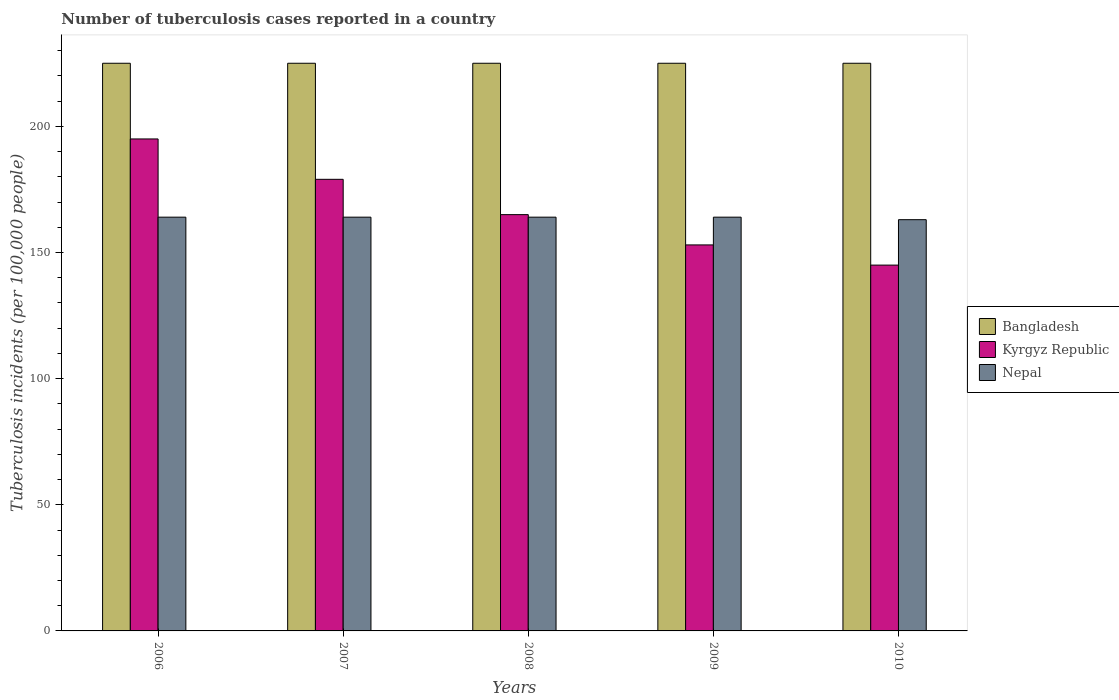How many groups of bars are there?
Provide a succinct answer. 5. What is the label of the 4th group of bars from the left?
Provide a succinct answer. 2009. What is the number of tuberculosis cases reported in in Kyrgyz Republic in 2010?
Provide a succinct answer. 145. Across all years, what is the maximum number of tuberculosis cases reported in in Bangladesh?
Provide a short and direct response. 225. Across all years, what is the minimum number of tuberculosis cases reported in in Bangladesh?
Keep it short and to the point. 225. In which year was the number of tuberculosis cases reported in in Kyrgyz Republic minimum?
Ensure brevity in your answer.  2010. What is the total number of tuberculosis cases reported in in Bangladesh in the graph?
Make the answer very short. 1125. What is the difference between the number of tuberculosis cases reported in in Nepal in 2007 and that in 2010?
Your answer should be very brief. 1. What is the difference between the number of tuberculosis cases reported in in Nepal in 2007 and the number of tuberculosis cases reported in in Bangladesh in 2009?
Your answer should be compact. -61. What is the average number of tuberculosis cases reported in in Nepal per year?
Your answer should be compact. 163.8. In the year 2007, what is the difference between the number of tuberculosis cases reported in in Kyrgyz Republic and number of tuberculosis cases reported in in Nepal?
Keep it short and to the point. 15. In how many years, is the number of tuberculosis cases reported in in Nepal greater than 90?
Your answer should be compact. 5. What is the ratio of the number of tuberculosis cases reported in in Kyrgyz Republic in 2009 to that in 2010?
Offer a terse response. 1.06. What is the difference between the highest and the lowest number of tuberculosis cases reported in in Bangladesh?
Make the answer very short. 0. Is the sum of the number of tuberculosis cases reported in in Nepal in 2007 and 2008 greater than the maximum number of tuberculosis cases reported in in Bangladesh across all years?
Your answer should be compact. Yes. What does the 3rd bar from the left in 2009 represents?
Offer a terse response. Nepal. Is it the case that in every year, the sum of the number of tuberculosis cases reported in in Nepal and number of tuberculosis cases reported in in Bangladesh is greater than the number of tuberculosis cases reported in in Kyrgyz Republic?
Your answer should be compact. Yes. Are all the bars in the graph horizontal?
Your answer should be very brief. No. How many years are there in the graph?
Make the answer very short. 5. Does the graph contain any zero values?
Your answer should be compact. No. Does the graph contain grids?
Offer a terse response. No. How many legend labels are there?
Provide a short and direct response. 3. What is the title of the graph?
Your response must be concise. Number of tuberculosis cases reported in a country. Does "Liberia" appear as one of the legend labels in the graph?
Make the answer very short. No. What is the label or title of the Y-axis?
Offer a terse response. Tuberculosis incidents (per 100,0 people). What is the Tuberculosis incidents (per 100,000 people) of Bangladesh in 2006?
Ensure brevity in your answer.  225. What is the Tuberculosis incidents (per 100,000 people) of Kyrgyz Republic in 2006?
Ensure brevity in your answer.  195. What is the Tuberculosis incidents (per 100,000 people) of Nepal in 2006?
Make the answer very short. 164. What is the Tuberculosis incidents (per 100,000 people) in Bangladesh in 2007?
Your answer should be compact. 225. What is the Tuberculosis incidents (per 100,000 people) of Kyrgyz Republic in 2007?
Make the answer very short. 179. What is the Tuberculosis incidents (per 100,000 people) of Nepal in 2007?
Keep it short and to the point. 164. What is the Tuberculosis incidents (per 100,000 people) in Bangladesh in 2008?
Provide a short and direct response. 225. What is the Tuberculosis incidents (per 100,000 people) of Kyrgyz Republic in 2008?
Provide a short and direct response. 165. What is the Tuberculosis incidents (per 100,000 people) of Nepal in 2008?
Ensure brevity in your answer.  164. What is the Tuberculosis incidents (per 100,000 people) in Bangladesh in 2009?
Your response must be concise. 225. What is the Tuberculosis incidents (per 100,000 people) in Kyrgyz Republic in 2009?
Give a very brief answer. 153. What is the Tuberculosis incidents (per 100,000 people) of Nepal in 2009?
Provide a succinct answer. 164. What is the Tuberculosis incidents (per 100,000 people) in Bangladesh in 2010?
Give a very brief answer. 225. What is the Tuberculosis incidents (per 100,000 people) in Kyrgyz Republic in 2010?
Provide a succinct answer. 145. What is the Tuberculosis incidents (per 100,000 people) in Nepal in 2010?
Offer a terse response. 163. Across all years, what is the maximum Tuberculosis incidents (per 100,000 people) of Bangladesh?
Give a very brief answer. 225. Across all years, what is the maximum Tuberculosis incidents (per 100,000 people) of Kyrgyz Republic?
Ensure brevity in your answer.  195. Across all years, what is the maximum Tuberculosis incidents (per 100,000 people) of Nepal?
Offer a terse response. 164. Across all years, what is the minimum Tuberculosis incidents (per 100,000 people) of Bangladesh?
Your response must be concise. 225. Across all years, what is the minimum Tuberculosis incidents (per 100,000 people) of Kyrgyz Republic?
Keep it short and to the point. 145. Across all years, what is the minimum Tuberculosis incidents (per 100,000 people) of Nepal?
Offer a terse response. 163. What is the total Tuberculosis incidents (per 100,000 people) in Bangladesh in the graph?
Keep it short and to the point. 1125. What is the total Tuberculosis incidents (per 100,000 people) of Kyrgyz Republic in the graph?
Your answer should be very brief. 837. What is the total Tuberculosis incidents (per 100,000 people) of Nepal in the graph?
Make the answer very short. 819. What is the difference between the Tuberculosis incidents (per 100,000 people) of Bangladesh in 2006 and that in 2007?
Offer a terse response. 0. What is the difference between the Tuberculosis incidents (per 100,000 people) of Nepal in 2006 and that in 2007?
Offer a terse response. 0. What is the difference between the Tuberculosis incidents (per 100,000 people) in Bangladesh in 2006 and that in 2008?
Ensure brevity in your answer.  0. What is the difference between the Tuberculosis incidents (per 100,000 people) in Nepal in 2006 and that in 2008?
Your answer should be compact. 0. What is the difference between the Tuberculosis incidents (per 100,000 people) of Bangladesh in 2006 and that in 2009?
Give a very brief answer. 0. What is the difference between the Tuberculosis incidents (per 100,000 people) in Nepal in 2006 and that in 2009?
Ensure brevity in your answer.  0. What is the difference between the Tuberculosis incidents (per 100,000 people) in Bangladesh in 2007 and that in 2009?
Your answer should be compact. 0. What is the difference between the Tuberculosis incidents (per 100,000 people) of Kyrgyz Republic in 2007 and that in 2009?
Provide a short and direct response. 26. What is the difference between the Tuberculosis incidents (per 100,000 people) in Nepal in 2007 and that in 2009?
Your response must be concise. 0. What is the difference between the Tuberculosis incidents (per 100,000 people) in Bangladesh in 2007 and that in 2010?
Provide a succinct answer. 0. What is the difference between the Tuberculosis incidents (per 100,000 people) in Kyrgyz Republic in 2007 and that in 2010?
Offer a terse response. 34. What is the difference between the Tuberculosis incidents (per 100,000 people) of Nepal in 2007 and that in 2010?
Ensure brevity in your answer.  1. What is the difference between the Tuberculosis incidents (per 100,000 people) of Bangladesh in 2008 and that in 2009?
Ensure brevity in your answer.  0. What is the difference between the Tuberculosis incidents (per 100,000 people) in Nepal in 2008 and that in 2009?
Your answer should be very brief. 0. What is the difference between the Tuberculosis incidents (per 100,000 people) of Bangladesh in 2008 and that in 2010?
Offer a very short reply. 0. What is the difference between the Tuberculosis incidents (per 100,000 people) in Kyrgyz Republic in 2008 and that in 2010?
Your answer should be very brief. 20. What is the difference between the Tuberculosis incidents (per 100,000 people) of Kyrgyz Republic in 2009 and that in 2010?
Offer a terse response. 8. What is the difference between the Tuberculosis incidents (per 100,000 people) in Kyrgyz Republic in 2006 and the Tuberculosis incidents (per 100,000 people) in Nepal in 2007?
Offer a very short reply. 31. What is the difference between the Tuberculosis incidents (per 100,000 people) of Bangladesh in 2006 and the Tuberculosis incidents (per 100,000 people) of Kyrgyz Republic in 2008?
Make the answer very short. 60. What is the difference between the Tuberculosis incidents (per 100,000 people) in Kyrgyz Republic in 2006 and the Tuberculosis incidents (per 100,000 people) in Nepal in 2008?
Keep it short and to the point. 31. What is the difference between the Tuberculosis incidents (per 100,000 people) in Bangladesh in 2006 and the Tuberculosis incidents (per 100,000 people) in Kyrgyz Republic in 2009?
Give a very brief answer. 72. What is the difference between the Tuberculosis incidents (per 100,000 people) in Bangladesh in 2006 and the Tuberculosis incidents (per 100,000 people) in Kyrgyz Republic in 2010?
Keep it short and to the point. 80. What is the difference between the Tuberculosis incidents (per 100,000 people) of Kyrgyz Republic in 2006 and the Tuberculosis incidents (per 100,000 people) of Nepal in 2010?
Your response must be concise. 32. What is the difference between the Tuberculosis incidents (per 100,000 people) in Bangladesh in 2007 and the Tuberculosis incidents (per 100,000 people) in Kyrgyz Republic in 2008?
Your response must be concise. 60. What is the difference between the Tuberculosis incidents (per 100,000 people) of Bangladesh in 2007 and the Tuberculosis incidents (per 100,000 people) of Nepal in 2008?
Your answer should be compact. 61. What is the difference between the Tuberculosis incidents (per 100,000 people) of Bangladesh in 2007 and the Tuberculosis incidents (per 100,000 people) of Nepal in 2009?
Your response must be concise. 61. What is the difference between the Tuberculosis incidents (per 100,000 people) in Kyrgyz Republic in 2007 and the Tuberculosis incidents (per 100,000 people) in Nepal in 2009?
Give a very brief answer. 15. What is the difference between the Tuberculosis incidents (per 100,000 people) of Bangladesh in 2008 and the Tuberculosis incidents (per 100,000 people) of Kyrgyz Republic in 2009?
Keep it short and to the point. 72. What is the difference between the Tuberculosis incidents (per 100,000 people) in Bangladesh in 2008 and the Tuberculosis incidents (per 100,000 people) in Nepal in 2009?
Ensure brevity in your answer.  61. What is the difference between the Tuberculosis incidents (per 100,000 people) in Kyrgyz Republic in 2008 and the Tuberculosis incidents (per 100,000 people) in Nepal in 2010?
Offer a terse response. 2. What is the difference between the Tuberculosis incidents (per 100,000 people) of Bangladesh in 2009 and the Tuberculosis incidents (per 100,000 people) of Kyrgyz Republic in 2010?
Offer a very short reply. 80. What is the difference between the Tuberculosis incidents (per 100,000 people) of Kyrgyz Republic in 2009 and the Tuberculosis incidents (per 100,000 people) of Nepal in 2010?
Your answer should be compact. -10. What is the average Tuberculosis incidents (per 100,000 people) in Bangladesh per year?
Offer a very short reply. 225. What is the average Tuberculosis incidents (per 100,000 people) of Kyrgyz Republic per year?
Your answer should be very brief. 167.4. What is the average Tuberculosis incidents (per 100,000 people) in Nepal per year?
Offer a very short reply. 163.8. In the year 2006, what is the difference between the Tuberculosis incidents (per 100,000 people) in Kyrgyz Republic and Tuberculosis incidents (per 100,000 people) in Nepal?
Give a very brief answer. 31. In the year 2007, what is the difference between the Tuberculosis incidents (per 100,000 people) of Bangladesh and Tuberculosis incidents (per 100,000 people) of Kyrgyz Republic?
Your answer should be compact. 46. In the year 2007, what is the difference between the Tuberculosis incidents (per 100,000 people) of Bangladesh and Tuberculosis incidents (per 100,000 people) of Nepal?
Your response must be concise. 61. In the year 2010, what is the difference between the Tuberculosis incidents (per 100,000 people) in Bangladesh and Tuberculosis incidents (per 100,000 people) in Kyrgyz Republic?
Keep it short and to the point. 80. In the year 2010, what is the difference between the Tuberculosis incidents (per 100,000 people) in Bangladesh and Tuberculosis incidents (per 100,000 people) in Nepal?
Ensure brevity in your answer.  62. What is the ratio of the Tuberculosis incidents (per 100,000 people) in Kyrgyz Republic in 2006 to that in 2007?
Make the answer very short. 1.09. What is the ratio of the Tuberculosis incidents (per 100,000 people) in Nepal in 2006 to that in 2007?
Keep it short and to the point. 1. What is the ratio of the Tuberculosis incidents (per 100,000 people) of Kyrgyz Republic in 2006 to that in 2008?
Your response must be concise. 1.18. What is the ratio of the Tuberculosis incidents (per 100,000 people) in Nepal in 2006 to that in 2008?
Provide a short and direct response. 1. What is the ratio of the Tuberculosis incidents (per 100,000 people) of Bangladesh in 2006 to that in 2009?
Give a very brief answer. 1. What is the ratio of the Tuberculosis incidents (per 100,000 people) of Kyrgyz Republic in 2006 to that in 2009?
Provide a short and direct response. 1.27. What is the ratio of the Tuberculosis incidents (per 100,000 people) of Bangladesh in 2006 to that in 2010?
Your answer should be compact. 1. What is the ratio of the Tuberculosis incidents (per 100,000 people) in Kyrgyz Republic in 2006 to that in 2010?
Make the answer very short. 1.34. What is the ratio of the Tuberculosis incidents (per 100,000 people) of Bangladesh in 2007 to that in 2008?
Your answer should be very brief. 1. What is the ratio of the Tuberculosis incidents (per 100,000 people) in Kyrgyz Republic in 2007 to that in 2008?
Provide a short and direct response. 1.08. What is the ratio of the Tuberculosis incidents (per 100,000 people) of Bangladesh in 2007 to that in 2009?
Offer a very short reply. 1. What is the ratio of the Tuberculosis incidents (per 100,000 people) in Kyrgyz Republic in 2007 to that in 2009?
Give a very brief answer. 1.17. What is the ratio of the Tuberculosis incidents (per 100,000 people) in Nepal in 2007 to that in 2009?
Your answer should be compact. 1. What is the ratio of the Tuberculosis incidents (per 100,000 people) in Bangladesh in 2007 to that in 2010?
Offer a very short reply. 1. What is the ratio of the Tuberculosis incidents (per 100,000 people) of Kyrgyz Republic in 2007 to that in 2010?
Keep it short and to the point. 1.23. What is the ratio of the Tuberculosis incidents (per 100,000 people) in Nepal in 2007 to that in 2010?
Offer a terse response. 1.01. What is the ratio of the Tuberculosis incidents (per 100,000 people) in Bangladesh in 2008 to that in 2009?
Keep it short and to the point. 1. What is the ratio of the Tuberculosis incidents (per 100,000 people) in Kyrgyz Republic in 2008 to that in 2009?
Give a very brief answer. 1.08. What is the ratio of the Tuberculosis incidents (per 100,000 people) in Bangladesh in 2008 to that in 2010?
Provide a short and direct response. 1. What is the ratio of the Tuberculosis incidents (per 100,000 people) in Kyrgyz Republic in 2008 to that in 2010?
Keep it short and to the point. 1.14. What is the ratio of the Tuberculosis incidents (per 100,000 people) in Kyrgyz Republic in 2009 to that in 2010?
Give a very brief answer. 1.06. What is the ratio of the Tuberculosis incidents (per 100,000 people) of Nepal in 2009 to that in 2010?
Your answer should be very brief. 1.01. What is the difference between the highest and the second highest Tuberculosis incidents (per 100,000 people) in Bangladesh?
Provide a short and direct response. 0. What is the difference between the highest and the lowest Tuberculosis incidents (per 100,000 people) of Nepal?
Provide a succinct answer. 1. 